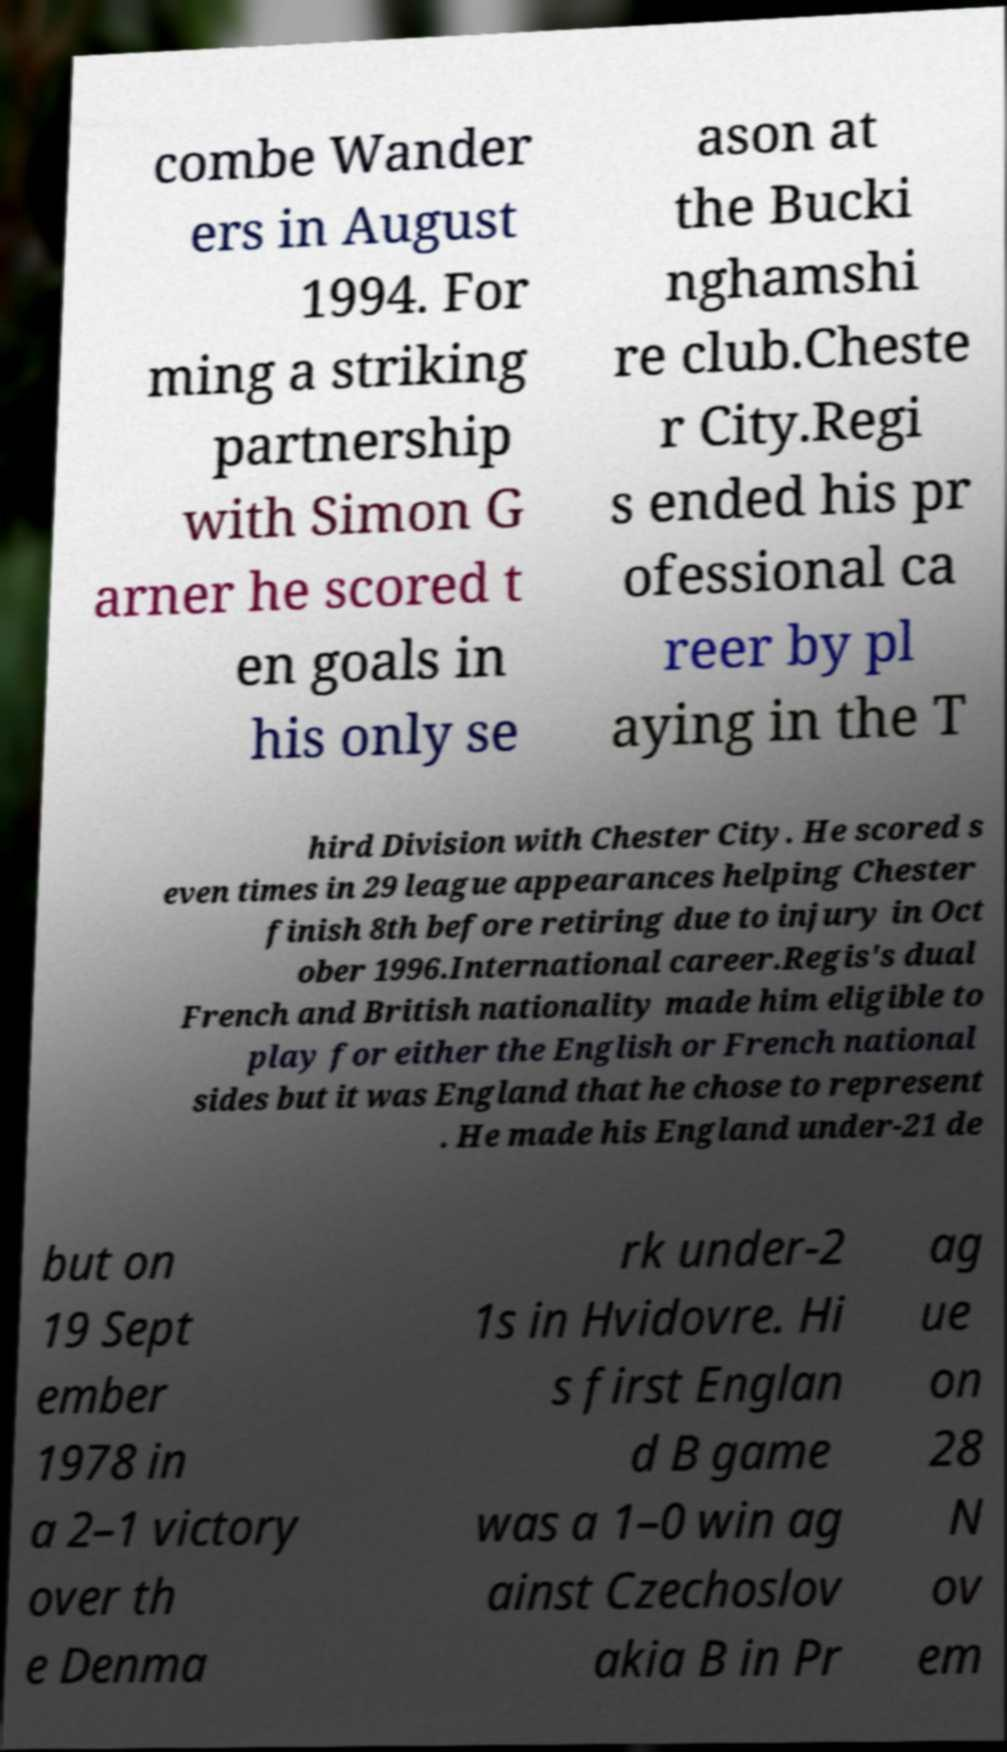What messages or text are displayed in this image? I need them in a readable, typed format. combe Wander ers in August 1994. For ming a striking partnership with Simon G arner he scored t en goals in his only se ason at the Bucki nghamshi re club.Cheste r City.Regi s ended his pr ofessional ca reer by pl aying in the T hird Division with Chester City. He scored s even times in 29 league appearances helping Chester finish 8th before retiring due to injury in Oct ober 1996.International career.Regis's dual French and British nationality made him eligible to play for either the English or French national sides but it was England that he chose to represent . He made his England under-21 de but on 19 Sept ember 1978 in a 2–1 victory over th e Denma rk under-2 1s in Hvidovre. Hi s first Englan d B game was a 1–0 win ag ainst Czechoslov akia B in Pr ag ue on 28 N ov em 